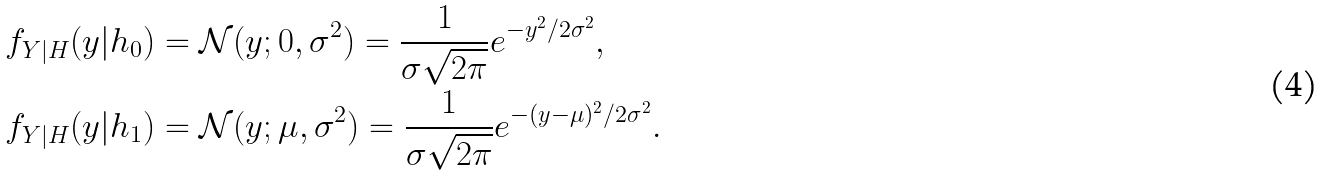<formula> <loc_0><loc_0><loc_500><loc_500>f _ { Y | H } ( y | h _ { 0 } ) & = \mathcal { N } ( y ; 0 , \sigma ^ { 2 } ) = \frac { 1 } { \sigma \sqrt { 2 \pi } } e ^ { - y ^ { 2 } / 2 \sigma ^ { 2 } } , \\ f _ { Y | H } ( y | h _ { 1 } ) & = \mathcal { N } ( y ; \mu , \sigma ^ { 2 } ) = \frac { 1 } { \sigma \sqrt { 2 \pi } } e ^ { - ( y - \mu ) ^ { 2 } / 2 \sigma ^ { 2 } } .</formula> 